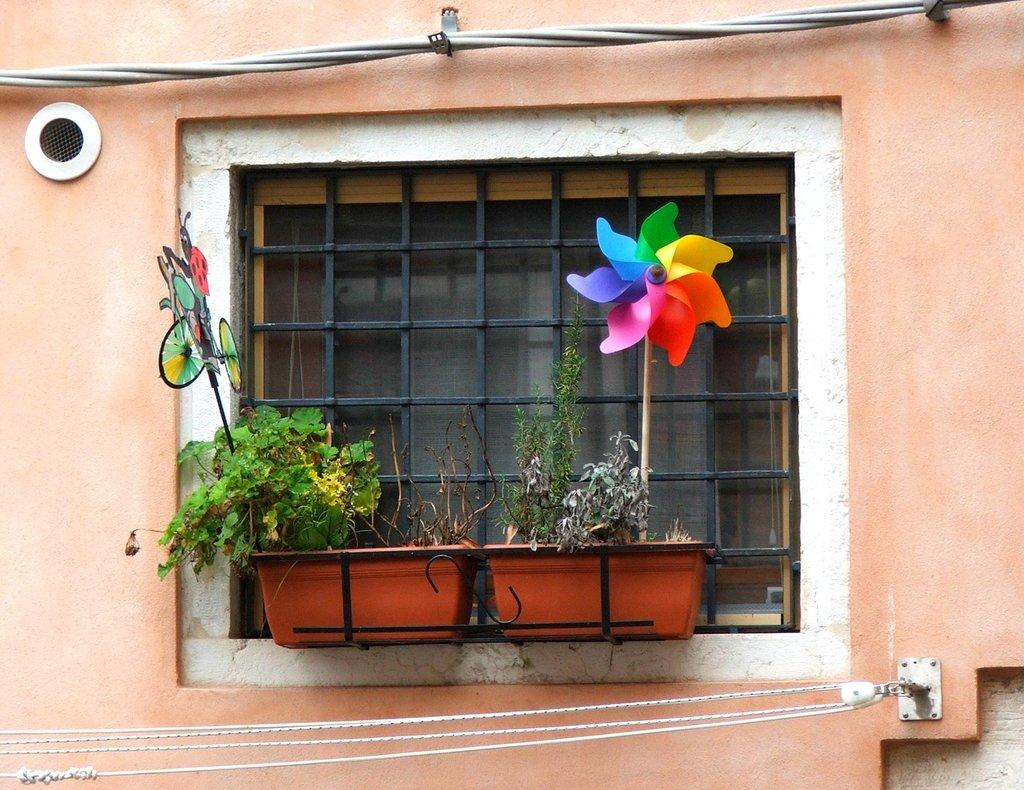What structure is present in the image that resembles a window? There is a window-like grill in the image. What is placed within the grill? There are plants in the grill. What type of material can be seen in the image? There is a wire visible in the image. What type of crafts are present in the image? There are paper crafts in different colors in the image. Can you tell me how many mice are hiding behind the paper crafts in the image? There are no mice present in the image; it only features plants, a window-like grill, a wire, and paper crafts. 